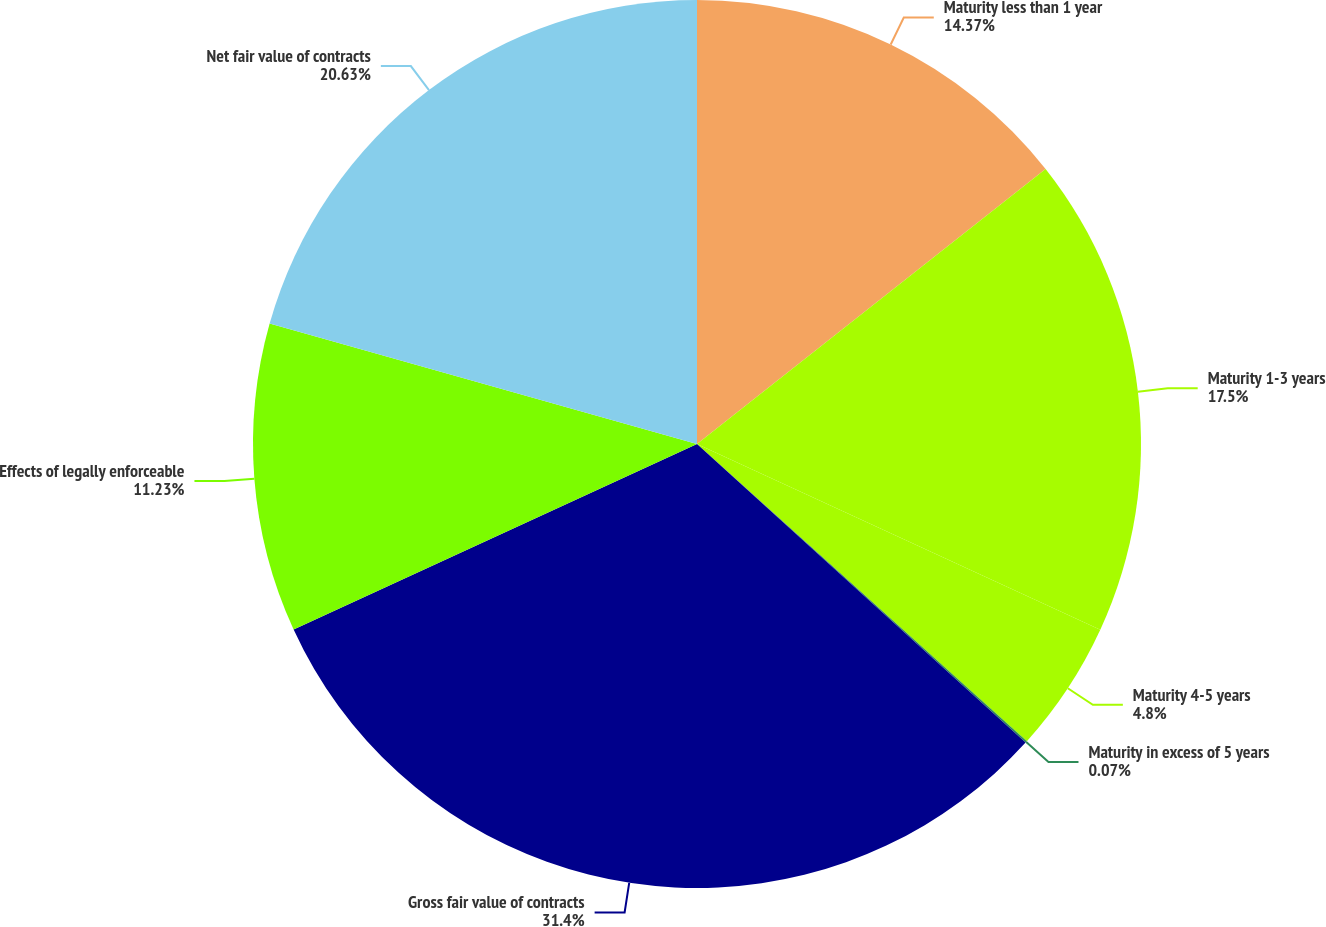<chart> <loc_0><loc_0><loc_500><loc_500><pie_chart><fcel>Maturity less than 1 year<fcel>Maturity 1-3 years<fcel>Maturity 4-5 years<fcel>Maturity in excess of 5 years<fcel>Gross fair value of contracts<fcel>Effects of legally enforceable<fcel>Net fair value of contracts<nl><fcel>14.37%<fcel>17.5%<fcel>4.8%<fcel>0.07%<fcel>31.4%<fcel>11.23%<fcel>20.63%<nl></chart> 